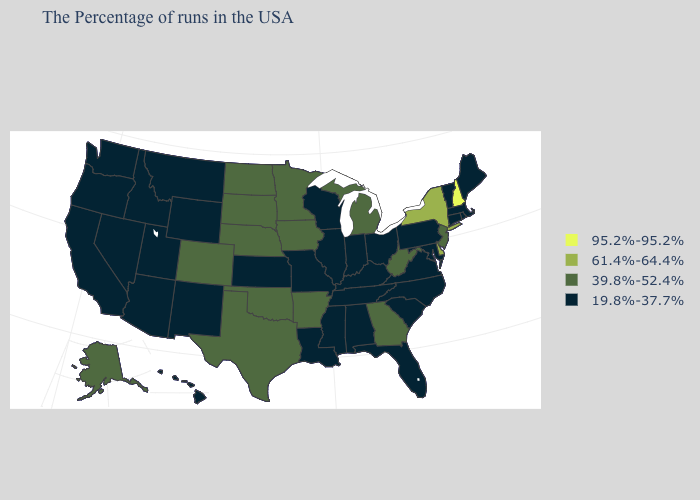How many symbols are there in the legend?
Short answer required. 4. Among the states that border Kentucky , which have the highest value?
Answer briefly. West Virginia. Does Iowa have the same value as New Jersey?
Keep it brief. Yes. Does New Hampshire have the highest value in the USA?
Short answer required. Yes. What is the value of Maine?
Be succinct. 19.8%-37.7%. What is the value of New Jersey?
Keep it brief. 39.8%-52.4%. Among the states that border Kansas , does Nebraska have the lowest value?
Write a very short answer. No. What is the lowest value in the Northeast?
Answer briefly. 19.8%-37.7%. What is the value of Hawaii?
Concise answer only. 19.8%-37.7%. Does the first symbol in the legend represent the smallest category?
Short answer required. No. What is the value of Wyoming?
Short answer required. 19.8%-37.7%. Among the states that border New York , does Vermont have the lowest value?
Short answer required. Yes. What is the lowest value in the USA?
Concise answer only. 19.8%-37.7%. Name the states that have a value in the range 19.8%-37.7%?
Short answer required. Maine, Massachusetts, Rhode Island, Vermont, Connecticut, Maryland, Pennsylvania, Virginia, North Carolina, South Carolina, Ohio, Florida, Kentucky, Indiana, Alabama, Tennessee, Wisconsin, Illinois, Mississippi, Louisiana, Missouri, Kansas, Wyoming, New Mexico, Utah, Montana, Arizona, Idaho, Nevada, California, Washington, Oregon, Hawaii. 